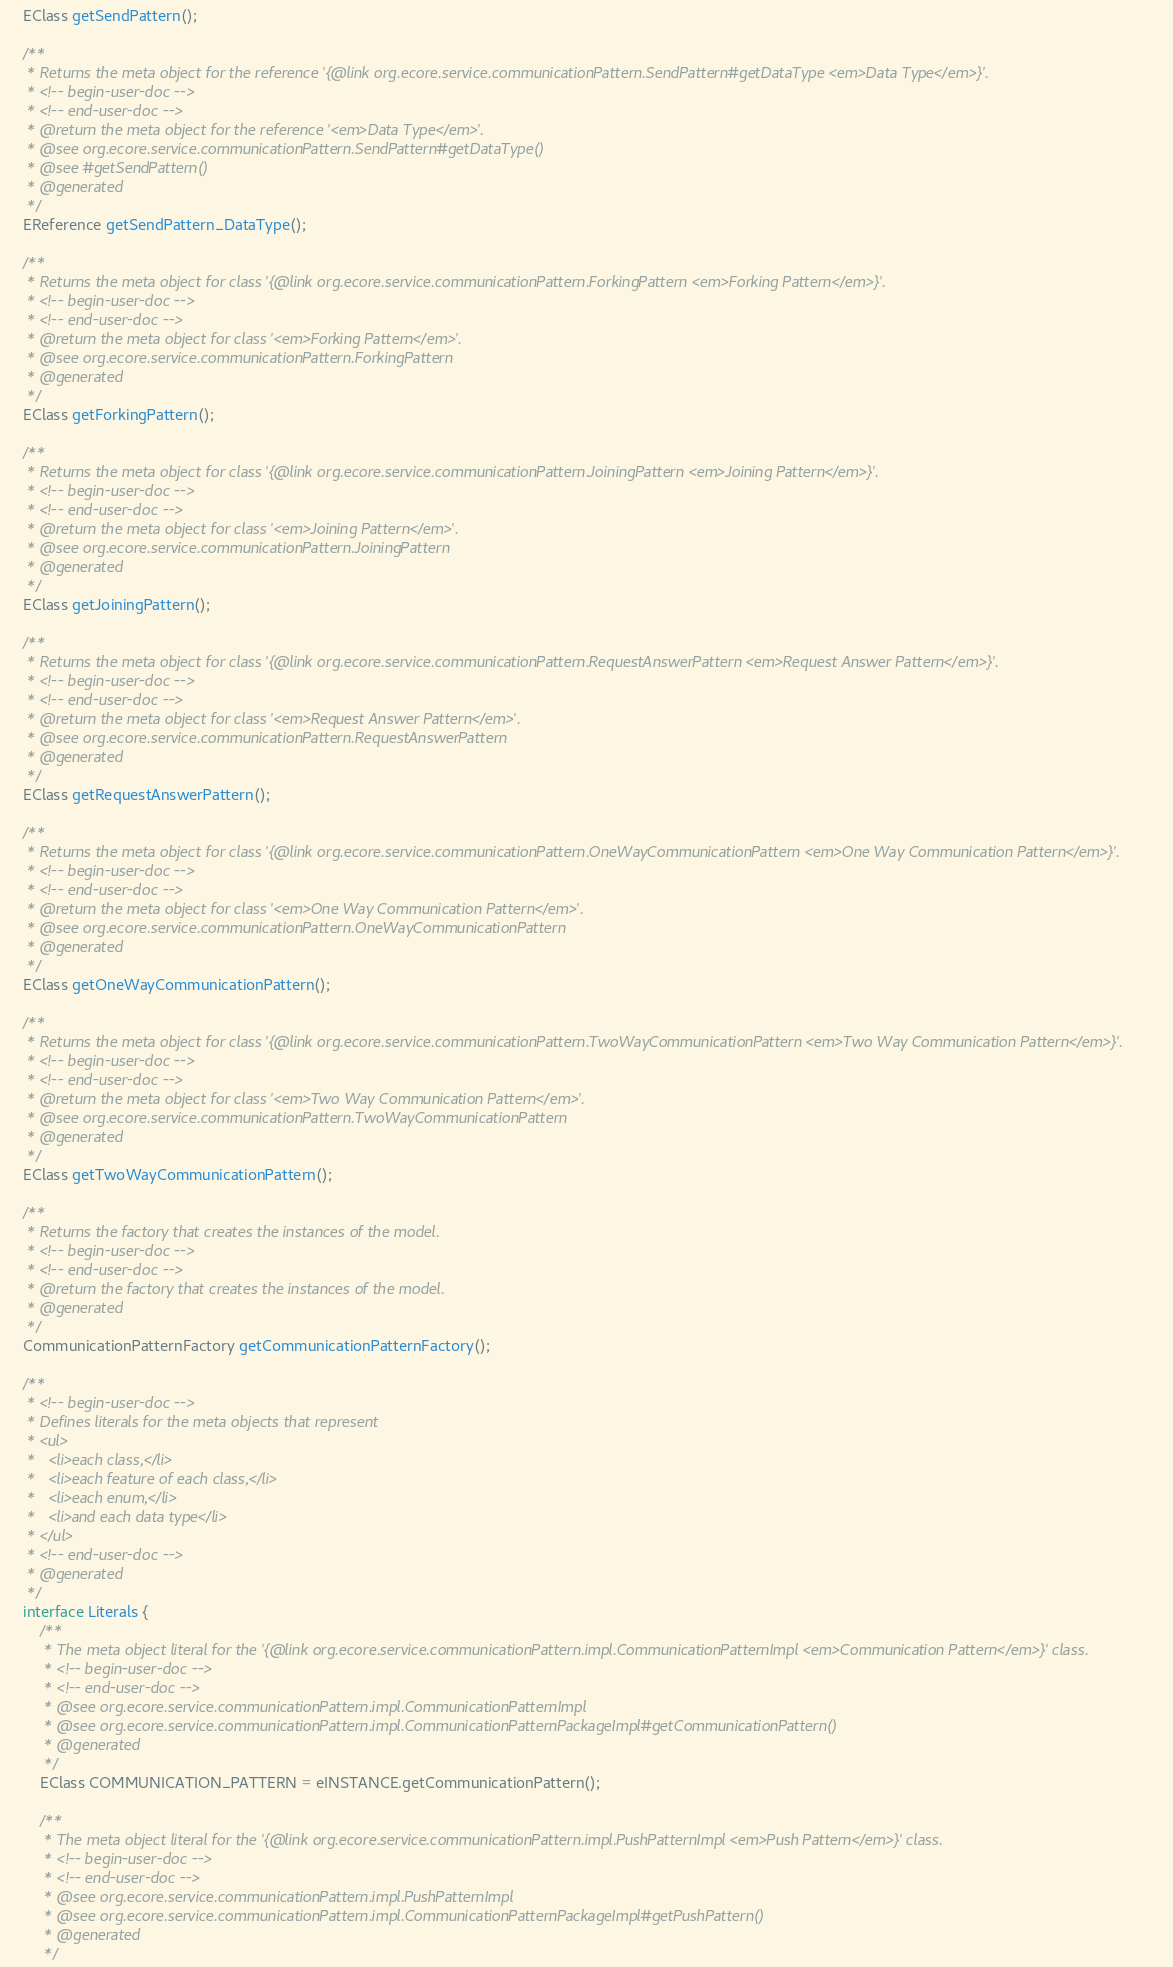Convert code to text. <code><loc_0><loc_0><loc_500><loc_500><_Java_>	EClass getSendPattern();

	/**
	 * Returns the meta object for the reference '{@link org.ecore.service.communicationPattern.SendPattern#getDataType <em>Data Type</em>}'.
	 * <!-- begin-user-doc -->
	 * <!-- end-user-doc -->
	 * @return the meta object for the reference '<em>Data Type</em>'.
	 * @see org.ecore.service.communicationPattern.SendPattern#getDataType()
	 * @see #getSendPattern()
	 * @generated
	 */
	EReference getSendPattern_DataType();

	/**
	 * Returns the meta object for class '{@link org.ecore.service.communicationPattern.ForkingPattern <em>Forking Pattern</em>}'.
	 * <!-- begin-user-doc -->
	 * <!-- end-user-doc -->
	 * @return the meta object for class '<em>Forking Pattern</em>'.
	 * @see org.ecore.service.communicationPattern.ForkingPattern
	 * @generated
	 */
	EClass getForkingPattern();

	/**
	 * Returns the meta object for class '{@link org.ecore.service.communicationPattern.JoiningPattern <em>Joining Pattern</em>}'.
	 * <!-- begin-user-doc -->
	 * <!-- end-user-doc -->
	 * @return the meta object for class '<em>Joining Pattern</em>'.
	 * @see org.ecore.service.communicationPattern.JoiningPattern
	 * @generated
	 */
	EClass getJoiningPattern();

	/**
	 * Returns the meta object for class '{@link org.ecore.service.communicationPattern.RequestAnswerPattern <em>Request Answer Pattern</em>}'.
	 * <!-- begin-user-doc -->
	 * <!-- end-user-doc -->
	 * @return the meta object for class '<em>Request Answer Pattern</em>'.
	 * @see org.ecore.service.communicationPattern.RequestAnswerPattern
	 * @generated
	 */
	EClass getRequestAnswerPattern();

	/**
	 * Returns the meta object for class '{@link org.ecore.service.communicationPattern.OneWayCommunicationPattern <em>One Way Communication Pattern</em>}'.
	 * <!-- begin-user-doc -->
	 * <!-- end-user-doc -->
	 * @return the meta object for class '<em>One Way Communication Pattern</em>'.
	 * @see org.ecore.service.communicationPattern.OneWayCommunicationPattern
	 * @generated
	 */
	EClass getOneWayCommunicationPattern();

	/**
	 * Returns the meta object for class '{@link org.ecore.service.communicationPattern.TwoWayCommunicationPattern <em>Two Way Communication Pattern</em>}'.
	 * <!-- begin-user-doc -->
	 * <!-- end-user-doc -->
	 * @return the meta object for class '<em>Two Way Communication Pattern</em>'.
	 * @see org.ecore.service.communicationPattern.TwoWayCommunicationPattern
	 * @generated
	 */
	EClass getTwoWayCommunicationPattern();

	/**
	 * Returns the factory that creates the instances of the model.
	 * <!-- begin-user-doc -->
	 * <!-- end-user-doc -->
	 * @return the factory that creates the instances of the model.
	 * @generated
	 */
	CommunicationPatternFactory getCommunicationPatternFactory();

	/**
	 * <!-- begin-user-doc -->
	 * Defines literals for the meta objects that represent
	 * <ul>
	 *   <li>each class,</li>
	 *   <li>each feature of each class,</li>
	 *   <li>each enum,</li>
	 *   <li>and each data type</li>
	 * </ul>
	 * <!-- end-user-doc -->
	 * @generated
	 */
	interface Literals {
		/**
		 * The meta object literal for the '{@link org.ecore.service.communicationPattern.impl.CommunicationPatternImpl <em>Communication Pattern</em>}' class.
		 * <!-- begin-user-doc -->
		 * <!-- end-user-doc -->
		 * @see org.ecore.service.communicationPattern.impl.CommunicationPatternImpl
		 * @see org.ecore.service.communicationPattern.impl.CommunicationPatternPackageImpl#getCommunicationPattern()
		 * @generated
		 */
		EClass COMMUNICATION_PATTERN = eINSTANCE.getCommunicationPattern();

		/**
		 * The meta object literal for the '{@link org.ecore.service.communicationPattern.impl.PushPatternImpl <em>Push Pattern</em>}' class.
		 * <!-- begin-user-doc -->
		 * <!-- end-user-doc -->
		 * @see org.ecore.service.communicationPattern.impl.PushPatternImpl
		 * @see org.ecore.service.communicationPattern.impl.CommunicationPatternPackageImpl#getPushPattern()
		 * @generated
		 */</code> 